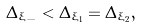<formula> <loc_0><loc_0><loc_500><loc_500>\Delta _ { \xi _ { - } } < \Delta _ { \xi _ { 1 } } = \Delta _ { \xi _ { 2 } } ,</formula> 